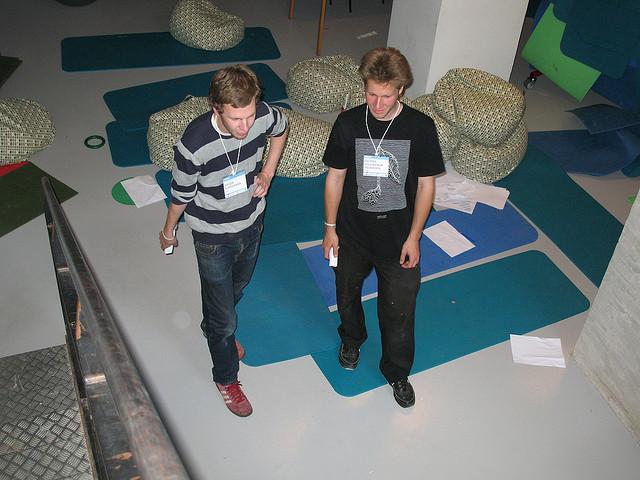What color are the mats on the floor?
Be succinct. Blue. How many bean bag chairs are in this photo?
Quick response, please. 8. What kind of hat is this guy wearing?
Write a very short answer. None. Are both men standing?
Give a very brief answer. Yes. What game console are the boys playing on?
Write a very short answer. Wii. 